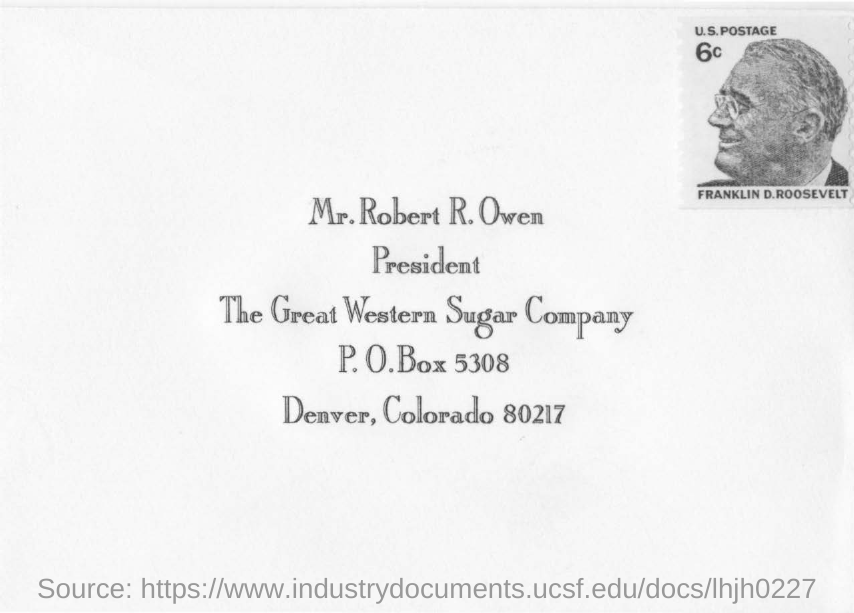Outline some significant characteristics in this image. The postal address mentions the name of Mr. Robert R. Owen. The post office box number is 5308. The envelope mentions The Great Western Sugar Company. The writing on the top left side of the envelope reads "Franklin D. Roosevelt. 